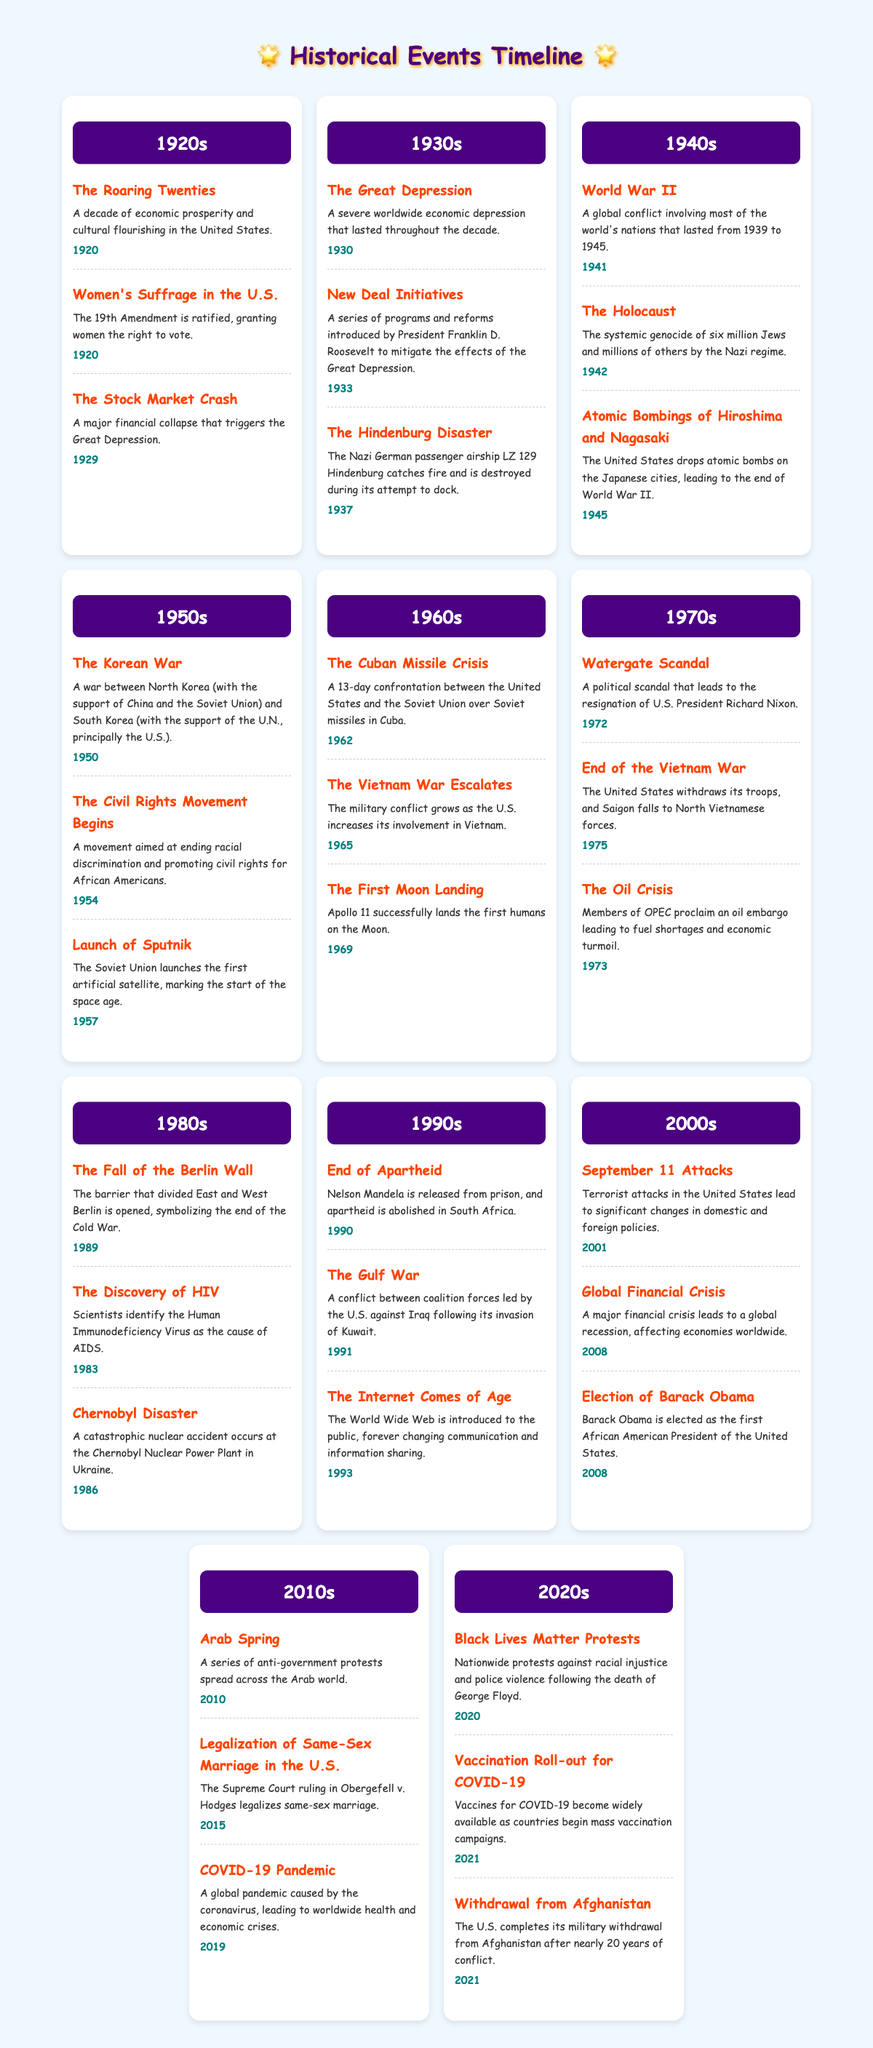What major financial event marked the end of the 1920s? The Stock Market Crash in 1929 is listed in the 1920s section of the table, marking a significant financial collapse that triggered the Great Depression.
Answer: The Stock Market Crash Which decade saw the start of the Civil Rights Movement? The Civil Rights Movement Begins is noted in the 1950s with a date of 1954, indicating that this decade was significant for the movement aimed at ending racial discrimination.
Answer: 1950s True or False: The First Moon Landing occurred in the 1970s. The table indicates that the First Moon Landing took place in 1969, which is in the 1960s, not the 1970s. Therefore, the statement is false.
Answer: False How many events mentioned in the 2000s occurred in the year 2008? In the 2000s section, two events occurred in 2008: the Global Financial Crisis and the Election of Barack Obama. Thus, there are two events listed for that year.
Answer: 2 What was the event that led to the resignation of U.S. President Richard Nixon? The table mentions the Watergate Scandal in the 1970s, which is directly linked to President Nixon's resignation in 1972.
Answer: Watergate Scandal How many significant events were listed in the 1990s? The table shows three events: the End of Apartheid in 1990, the Gulf War in 1991, and The Internet Comes of Age in 1993. Therefore, the total number of significant events in the 1990s is three.
Answer: 3 What was the primary issue addressed by the Women's Suffrage movement mentioned in the 1920s? The Women's Suffrage in the U.S. event in the 1920s highlights the ratification of the 19th Amendment, which granted women the right to vote. Therefore, the primary issue was women's voting rights.
Answer: Women's voting rights What are the two events that occurred in 2021 according to the table? The two events listed in the 2020s that occurred in 2021 are the Vaccination Roll-out for COVID-19 and the Withdrawal from Afghanistan, indicating significant developments in public health and military affairs.
Answer: Vaccination Roll-out for COVID-19 and Withdrawal from Afghanistan 